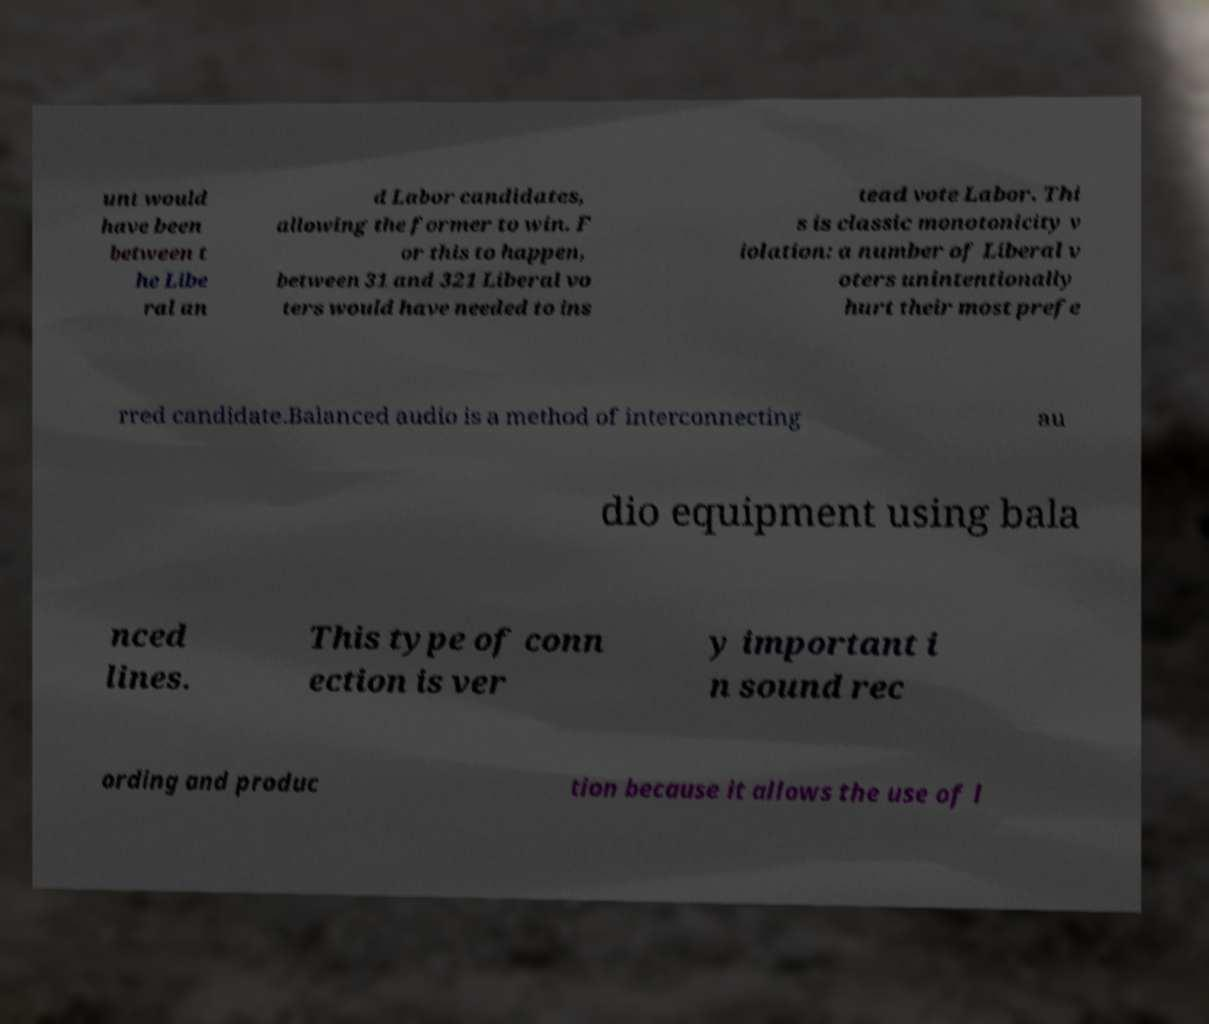I need the written content from this picture converted into text. Can you do that? unt would have been between t he Libe ral an d Labor candidates, allowing the former to win. F or this to happen, between 31 and 321 Liberal vo ters would have needed to ins tead vote Labor. Thi s is classic monotonicity v iolation: a number of Liberal v oters unintentionally hurt their most prefe rred candidate.Balanced audio is a method of interconnecting au dio equipment using bala nced lines. This type of conn ection is ver y important i n sound rec ording and produc tion because it allows the use of l 